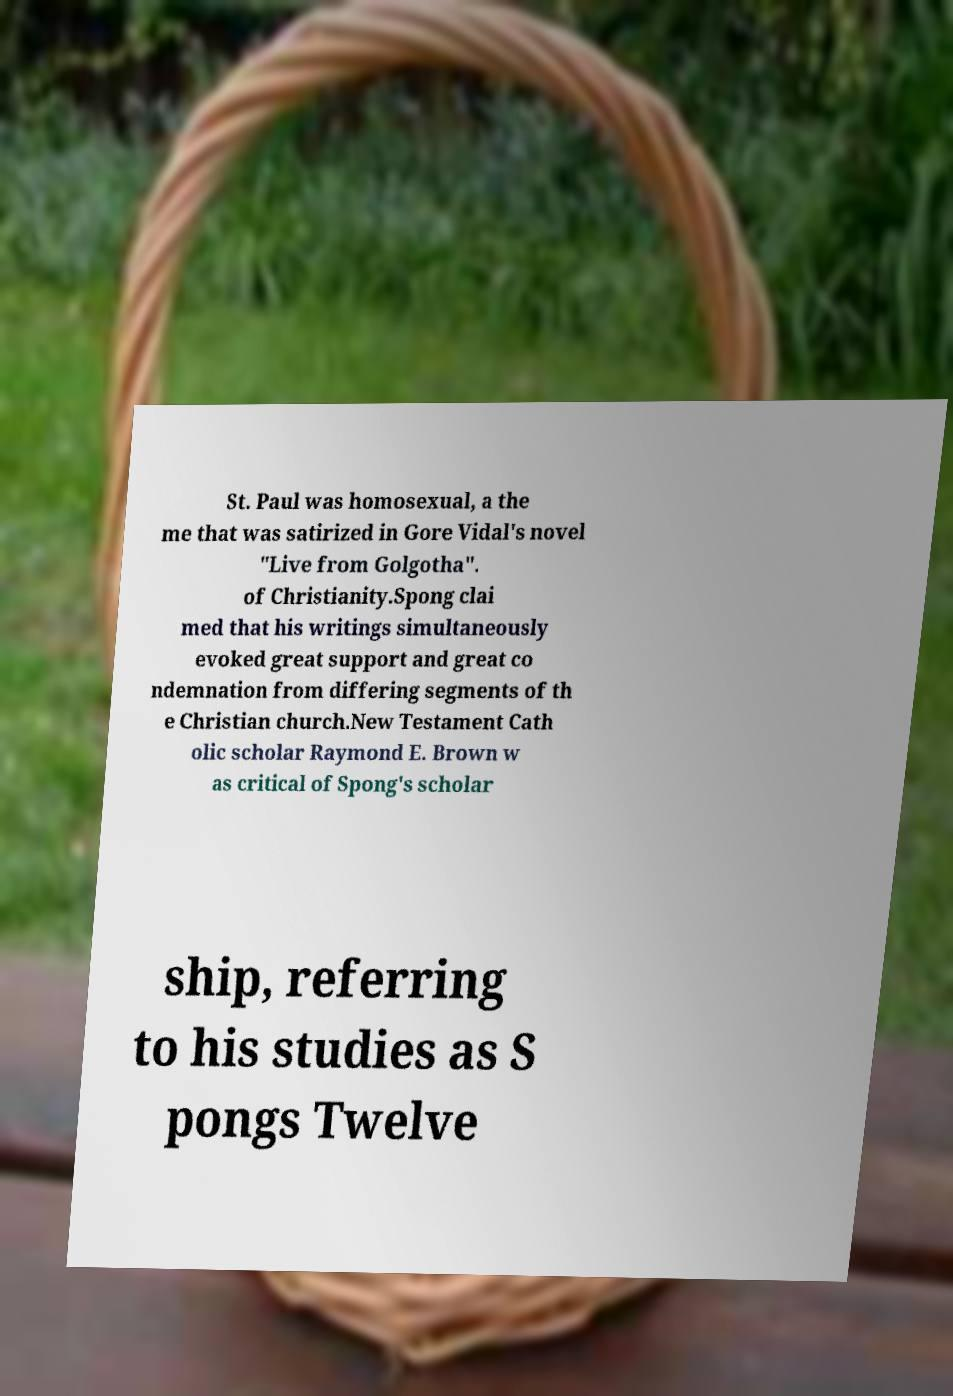Can you accurately transcribe the text from the provided image for me? St. Paul was homosexual, a the me that was satirized in Gore Vidal's novel "Live from Golgotha". of Christianity.Spong clai med that his writings simultaneously evoked great support and great co ndemnation from differing segments of th e Christian church.New Testament Cath olic scholar Raymond E. Brown w as critical of Spong's scholar ship, referring to his studies as S pongs Twelve 